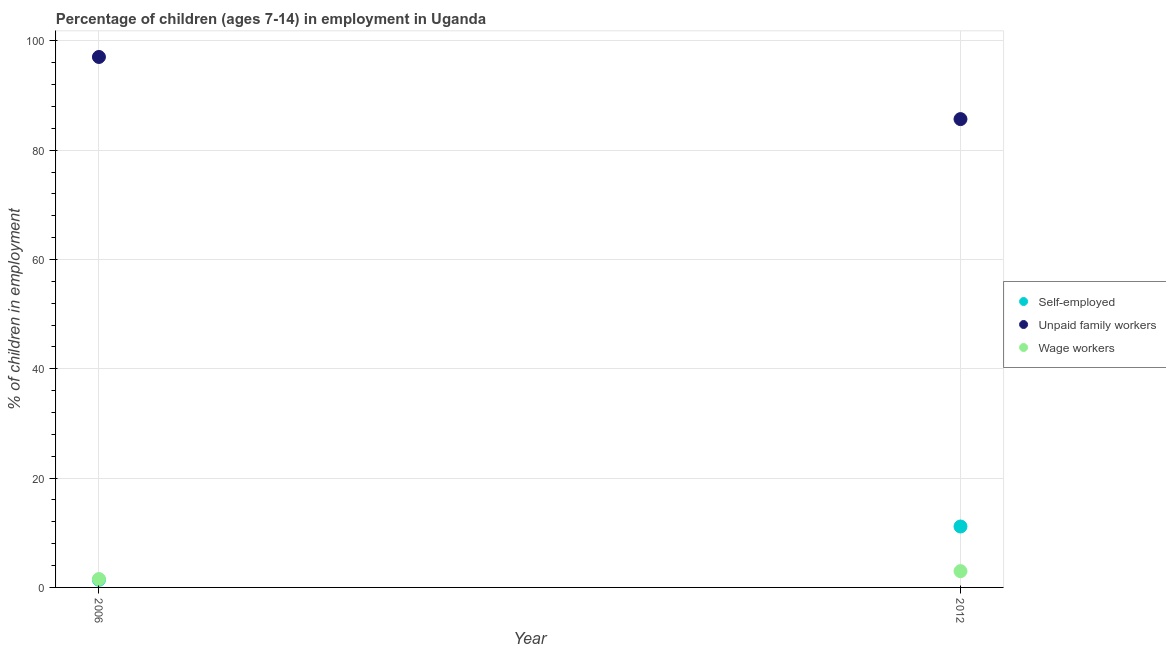Is the number of dotlines equal to the number of legend labels?
Your answer should be compact. Yes. What is the percentage of children employed as wage workers in 2006?
Your answer should be compact. 1.53. Across all years, what is the maximum percentage of self employed children?
Give a very brief answer. 11.15. Across all years, what is the minimum percentage of children employed as unpaid family workers?
Ensure brevity in your answer.  85.7. In which year was the percentage of children employed as wage workers minimum?
Make the answer very short. 2006. What is the total percentage of children employed as unpaid family workers in the graph?
Ensure brevity in your answer.  182.77. What is the difference between the percentage of children employed as wage workers in 2006 and that in 2012?
Offer a very short reply. -1.45. What is the difference between the percentage of self employed children in 2006 and the percentage of children employed as unpaid family workers in 2012?
Give a very brief answer. -84.3. What is the average percentage of children employed as wage workers per year?
Provide a succinct answer. 2.25. In the year 2012, what is the difference between the percentage of self employed children and percentage of children employed as wage workers?
Provide a succinct answer. 8.17. What is the ratio of the percentage of children employed as unpaid family workers in 2006 to that in 2012?
Your response must be concise. 1.13. Is it the case that in every year, the sum of the percentage of self employed children and percentage of children employed as unpaid family workers is greater than the percentage of children employed as wage workers?
Provide a succinct answer. Yes. Does the percentage of self employed children monotonically increase over the years?
Provide a short and direct response. Yes. Is the percentage of self employed children strictly greater than the percentage of children employed as unpaid family workers over the years?
Your response must be concise. No. How many dotlines are there?
Your response must be concise. 3. What is the difference between two consecutive major ticks on the Y-axis?
Offer a terse response. 20. Does the graph contain any zero values?
Provide a succinct answer. No. Does the graph contain grids?
Provide a succinct answer. Yes. Where does the legend appear in the graph?
Make the answer very short. Center right. How are the legend labels stacked?
Give a very brief answer. Vertical. What is the title of the graph?
Your answer should be very brief. Percentage of children (ages 7-14) in employment in Uganda. What is the label or title of the Y-axis?
Provide a succinct answer. % of children in employment. What is the % of children in employment of Self-employed in 2006?
Keep it short and to the point. 1.4. What is the % of children in employment of Unpaid family workers in 2006?
Make the answer very short. 97.07. What is the % of children in employment in Wage workers in 2006?
Keep it short and to the point. 1.53. What is the % of children in employment in Self-employed in 2012?
Provide a short and direct response. 11.15. What is the % of children in employment in Unpaid family workers in 2012?
Give a very brief answer. 85.7. What is the % of children in employment in Wage workers in 2012?
Provide a succinct answer. 2.98. Across all years, what is the maximum % of children in employment in Self-employed?
Ensure brevity in your answer.  11.15. Across all years, what is the maximum % of children in employment of Unpaid family workers?
Your answer should be compact. 97.07. Across all years, what is the maximum % of children in employment in Wage workers?
Provide a short and direct response. 2.98. Across all years, what is the minimum % of children in employment in Self-employed?
Offer a terse response. 1.4. Across all years, what is the minimum % of children in employment of Unpaid family workers?
Provide a succinct answer. 85.7. Across all years, what is the minimum % of children in employment in Wage workers?
Ensure brevity in your answer.  1.53. What is the total % of children in employment in Self-employed in the graph?
Your answer should be compact. 12.55. What is the total % of children in employment of Unpaid family workers in the graph?
Offer a very short reply. 182.77. What is the total % of children in employment of Wage workers in the graph?
Offer a very short reply. 4.51. What is the difference between the % of children in employment in Self-employed in 2006 and that in 2012?
Provide a short and direct response. -9.75. What is the difference between the % of children in employment in Unpaid family workers in 2006 and that in 2012?
Ensure brevity in your answer.  11.37. What is the difference between the % of children in employment in Wage workers in 2006 and that in 2012?
Offer a very short reply. -1.45. What is the difference between the % of children in employment in Self-employed in 2006 and the % of children in employment in Unpaid family workers in 2012?
Provide a succinct answer. -84.3. What is the difference between the % of children in employment of Self-employed in 2006 and the % of children in employment of Wage workers in 2012?
Provide a short and direct response. -1.58. What is the difference between the % of children in employment in Unpaid family workers in 2006 and the % of children in employment in Wage workers in 2012?
Give a very brief answer. 94.09. What is the average % of children in employment in Self-employed per year?
Give a very brief answer. 6.28. What is the average % of children in employment in Unpaid family workers per year?
Keep it short and to the point. 91.39. What is the average % of children in employment in Wage workers per year?
Offer a terse response. 2.25. In the year 2006, what is the difference between the % of children in employment in Self-employed and % of children in employment in Unpaid family workers?
Offer a terse response. -95.67. In the year 2006, what is the difference between the % of children in employment of Self-employed and % of children in employment of Wage workers?
Your answer should be compact. -0.13. In the year 2006, what is the difference between the % of children in employment of Unpaid family workers and % of children in employment of Wage workers?
Your answer should be very brief. 95.54. In the year 2012, what is the difference between the % of children in employment of Self-employed and % of children in employment of Unpaid family workers?
Your answer should be compact. -74.55. In the year 2012, what is the difference between the % of children in employment of Self-employed and % of children in employment of Wage workers?
Give a very brief answer. 8.17. In the year 2012, what is the difference between the % of children in employment in Unpaid family workers and % of children in employment in Wage workers?
Offer a very short reply. 82.72. What is the ratio of the % of children in employment in Self-employed in 2006 to that in 2012?
Offer a terse response. 0.13. What is the ratio of the % of children in employment of Unpaid family workers in 2006 to that in 2012?
Your answer should be very brief. 1.13. What is the ratio of the % of children in employment of Wage workers in 2006 to that in 2012?
Your answer should be compact. 0.51. What is the difference between the highest and the second highest % of children in employment of Self-employed?
Provide a short and direct response. 9.75. What is the difference between the highest and the second highest % of children in employment in Unpaid family workers?
Offer a terse response. 11.37. What is the difference between the highest and the second highest % of children in employment in Wage workers?
Offer a terse response. 1.45. What is the difference between the highest and the lowest % of children in employment in Self-employed?
Give a very brief answer. 9.75. What is the difference between the highest and the lowest % of children in employment of Unpaid family workers?
Give a very brief answer. 11.37. What is the difference between the highest and the lowest % of children in employment of Wage workers?
Ensure brevity in your answer.  1.45. 